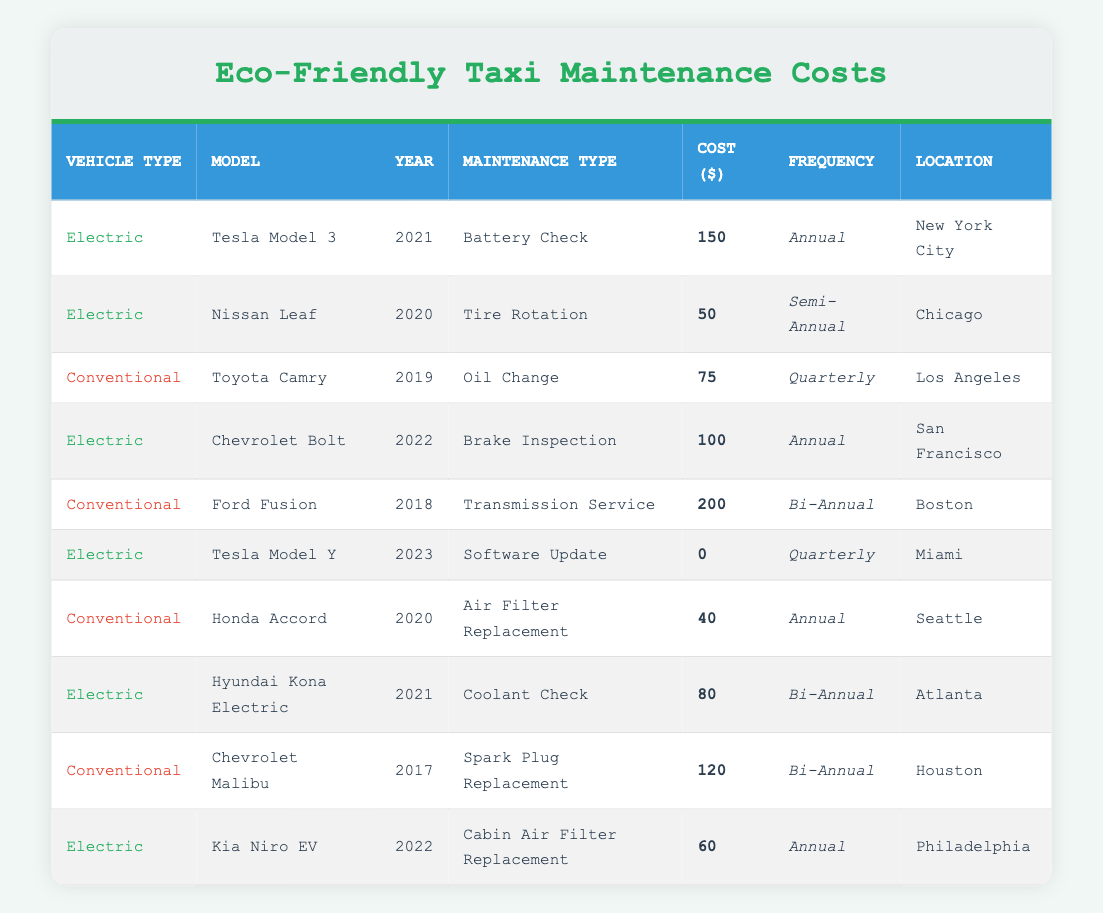What is the highest maintenance cost for electric taxis in the table? The highest maintenance cost for electric taxis is found in the row for the Tesla Model 3, which has a cost of 150. I read the costs in the "Cost ($)" column and identified the electric vehicle types. The highest among those is 150 for the Tesla Model 3.
Answer: 150 How many different types of maintenance are recorded for conventional taxis? The table shows three different maintenance types for conventional taxis: Oil Change, Transmission Service, and Air Filter Replacement. I counted the unique maintenance types specifically for the vehicles labeled as conventional.
Answer: 3 What is the average maintenance cost of electric taxis? To find the average cost of electric taxis, I sum the individual costs: 150 (Tesla Model 3) + 50 (Nissan Leaf) + 100 (Chevrolet Bolt) + 0 (Tesla Model Y) + 80 (Hyundai Kona Electric) + 60 (Kia Niro EV) = 440. There are 6 electric taxi entries, thus the average cost is 440/6 = 73.33.
Answer: 73.33 Is the maintenance cost of Ford Fusion higher than that of Kia Niro EV? The cost for Ford Fusion is 200, and for Kia Niro EV, it is 60. Comparing the two values shows that 200 is indeed higher than 60, making this statement true.
Answer: Yes Which maintenance type is performed most frequently on electric vehicles? By reviewing the table, I see that "Annual" maintenance frequency appears for both the Tesla Model 3 and the Chevrolet Bolt, with four instances of semi-annual and quarterly inspections across the electric taxis. However, "Annual" is the highest frequency given the number of entries compared.
Answer: Annual What is the total maintenance cost difference between electric and conventional taxis? First, I calculated the total cost for electric taxis: 150 + 50 + 100 + 0 + 80 + 60 = 440. Then I calculated for conventional taxis: 75 + 200 + 40 + 120 = 435. The difference is 440 - 435 = 5, indicating electric taxis cost 5 more.
Answer: 5 How many electric vehicles have a maintenance cost of 0? There is one entry in the electric category for the Tesla Model Y with a maintenance cost of 0. I checked the costs for all electric vehicles listed to find any that match 0.
Answer: 1 Is the maintenance frequency for the Nissan Leaf semi-annual? Yes, the Nissan Leaf is designated with a semi-annual frequency for Tire Rotation. I confirmed this by locating the Nissan Leaf entry and checking the "Frequency" column.
Answer: Yes 